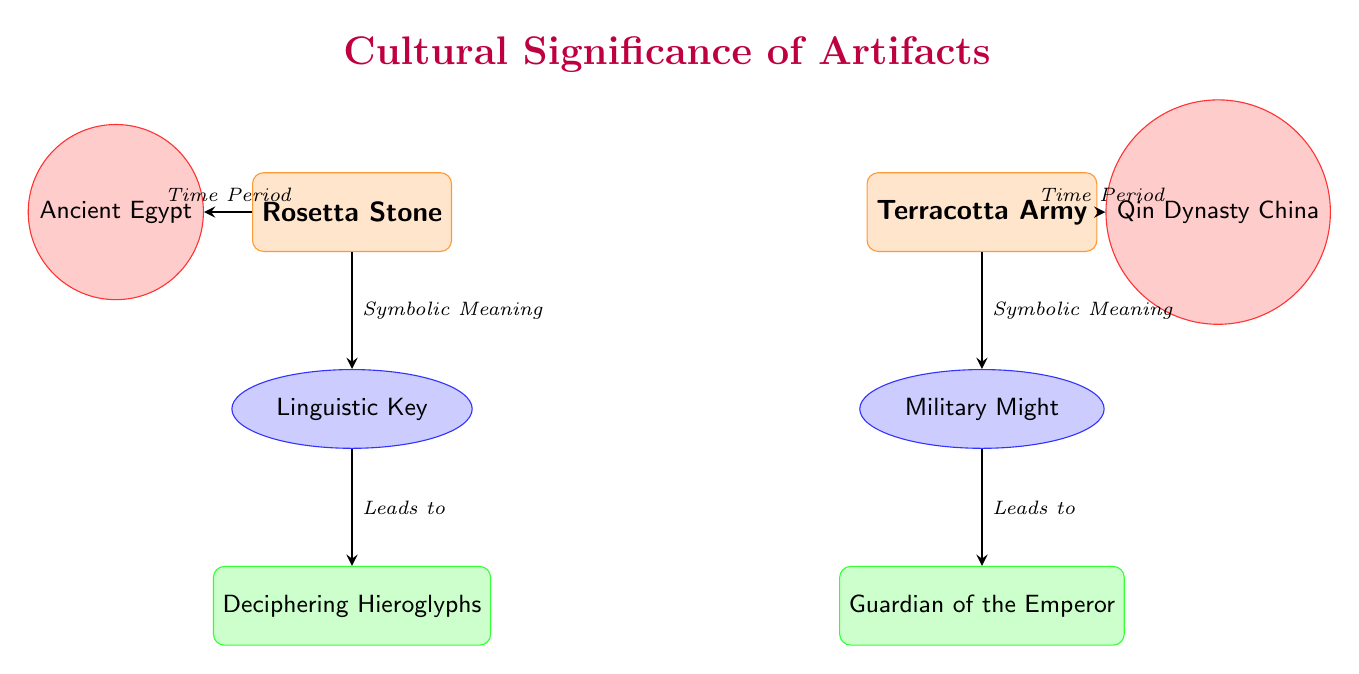What is the symbolic meaning of the Rosetta Stone? The diagram states that the symbolic meaning of the Rosetta Stone is "Linguistic Key." This can be found directly connected to the artifact node of the Rosetta Stone.
Answer: Linguistic Key What function is associated with the Terracotta Army? From the diagram, the Terracotta Army has the associated function labeled as "Guardian of the Emperor," which is connected to its symbolic meaning.
Answer: Guardian of the Emperor How many artifacts are represented in the diagram? The diagram shows two artifacts: the Rosetta Stone and the Terracotta Army. By counting the artifact nodes, we determine the total is two.
Answer: 2 What time period is associated with the Rosetta Stone? According to the diagram, the time period associated with the Rosetta Stone is indicated as "Ancient Egypt," which is connected to the artifact node.
Answer: Ancient Egypt What leads to the function of deciphering hieroglyphs? The diagram indicates that "Linguistic Key" leads to the function of "Deciphering Hieroglyphs." Therefore, the source of this function is the symbolic meaning associated with the Rosetta Stone.
Answer: Linguistic Key What is the relationship between the Terracotta Army and military might? The diagram shows a direct connection where "Military Might" is the symbolic meaning attributed to the Terracotta Army. This relationship denotes how the Terracotta Army symbolizes military power.
Answer: Symbolic Meaning What are the two cultural functions depicted in the diagram? The diagram outlines two cultural functions: "Deciphering Hieroglyphs" and "Guardian of the Emperor." These are directly connected to their respective symbolic meanings.
Answer: Deciphering Hieroglyphs, Guardian of the Emperor What is the connection direction for the arrow from the Terracotta Army to its function? The arrow from the Terracotta Army to its function ("Guardian of the Emperor") indicates the direction where the symbolic meaning leads to the function. This direction showcases causality between meaning and function.
Answer: Leads to What is the shape used to represent artifacts in the diagram? The artifacts in the diagram are represented using a rectangle shape. This specific style differentiates them from other node types in the diagram.
Answer: Rectangle What color is used to depict the symbolic meanings in the diagram? The symbolic meanings are represented with an ellipse shape filled with blue color according to the diagram's design scheme.
Answer: Blue 